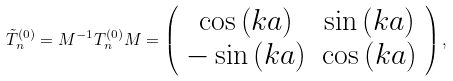Convert formula to latex. <formula><loc_0><loc_0><loc_500><loc_500>\tilde { T } _ { n } ^ { ( 0 ) } = { M } ^ { - 1 } { T } _ { n } ^ { ( 0 ) } { M } = \left ( \begin{array} { c c } \cos \left ( k a \right ) & \sin \left ( k a \right ) \\ - \sin \left ( k a \right ) & \cos \left ( k a \right ) \\ \end{array} \right ) ,</formula> 